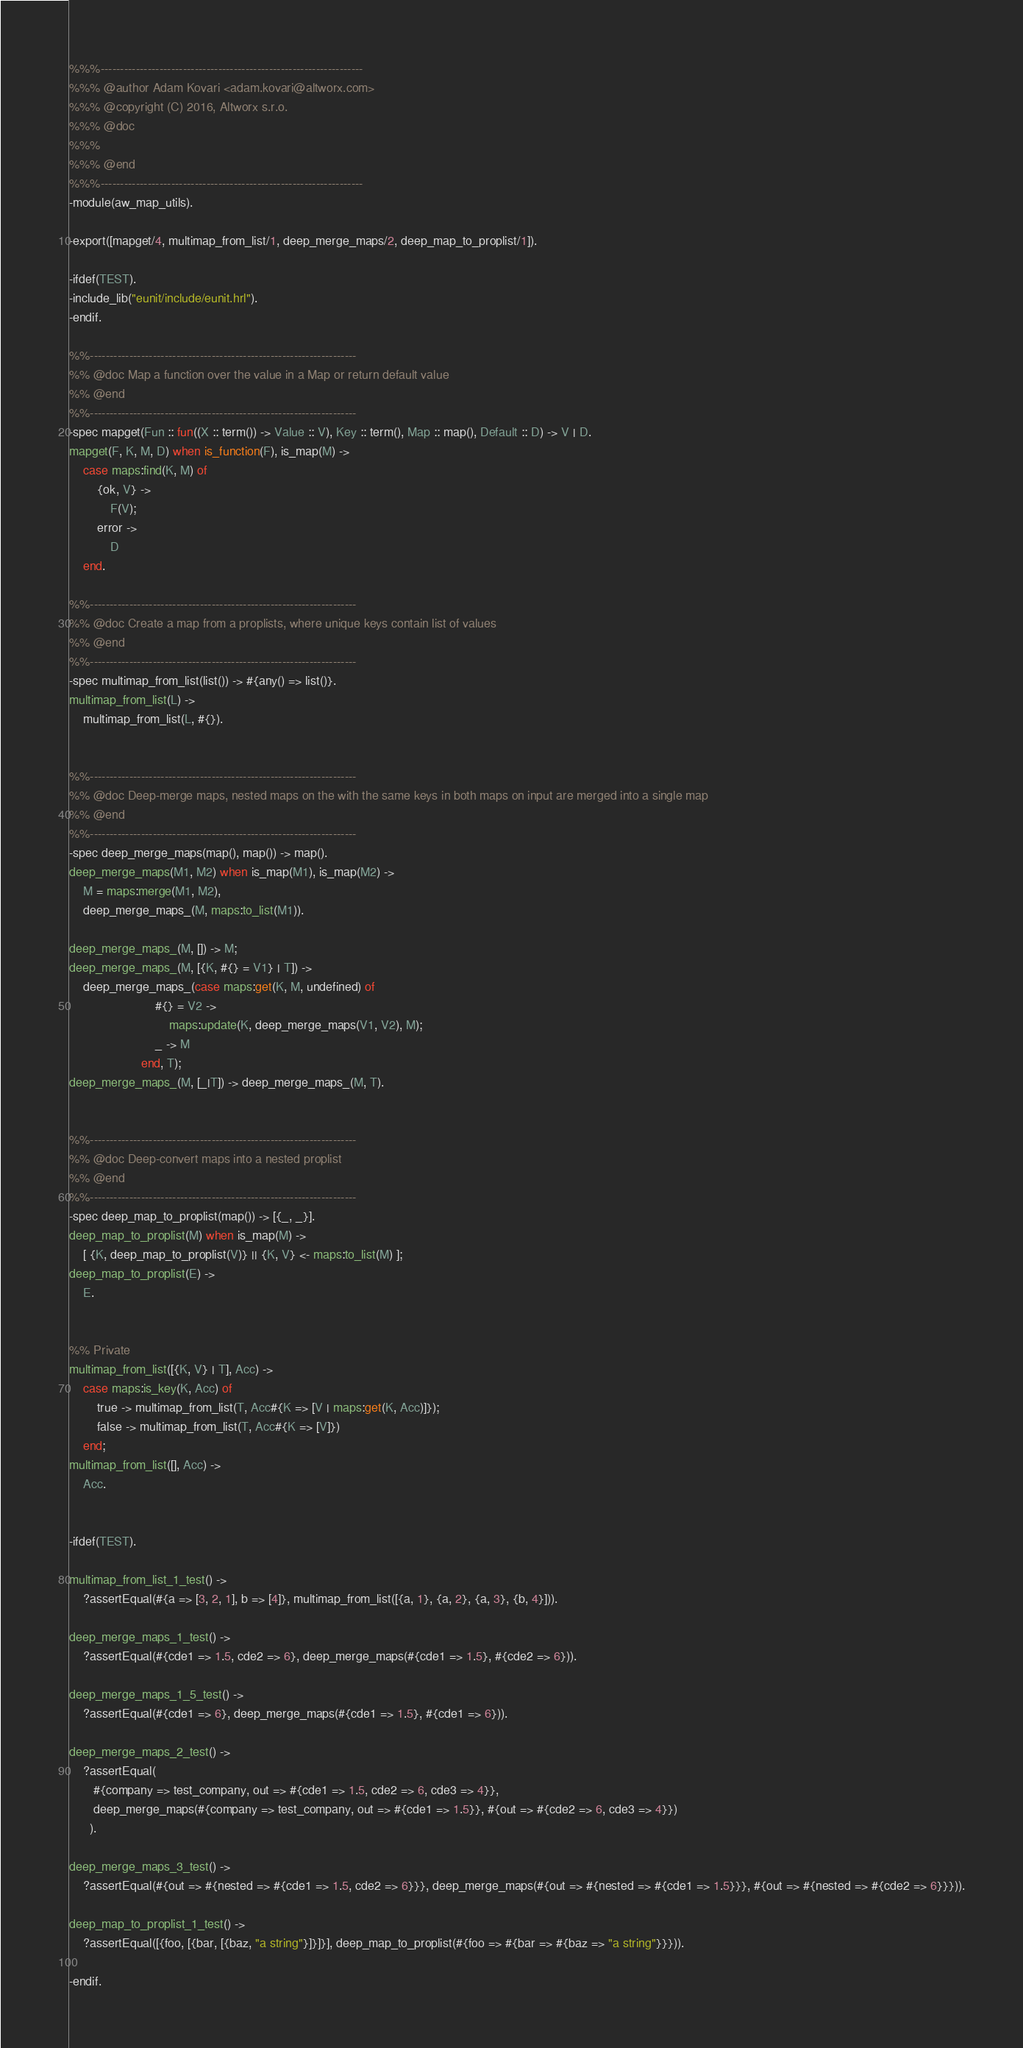<code> <loc_0><loc_0><loc_500><loc_500><_Erlang_>%%%-------------------------------------------------------------------
%%% @author Adam Kovari <adam.kovari@altworx.com>
%%% @copyright (C) 2016, Altworx s.r.o.
%%% @doc
%%%
%%% @end
%%%-------------------------------------------------------------------
-module(aw_map_utils).

-export([mapget/4, multimap_from_list/1, deep_merge_maps/2, deep_map_to_proplist/1]).

-ifdef(TEST).
-include_lib("eunit/include/eunit.hrl").
-endif.

%%--------------------------------------------------------------------
%% @doc Map a function over the value in a Map or return default value
%% @end
%%--------------------------------------------------------------------
-spec mapget(Fun :: fun((X :: term()) -> Value :: V), Key :: term(), Map :: map(), Default :: D) -> V | D.
mapget(F, K, M, D) when is_function(F), is_map(M) ->
    case maps:find(K, M) of
        {ok, V} ->
            F(V);
        error ->
            D
    end.

%%--------------------------------------------------------------------
%% @doc Create a map from a proplists, where unique keys contain list of values
%% @end
%%--------------------------------------------------------------------
-spec multimap_from_list(list()) -> #{any() => list()}.
multimap_from_list(L) ->
    multimap_from_list(L, #{}).


%%--------------------------------------------------------------------
%% @doc Deep-merge maps, nested maps on the with the same keys in both maps on input are merged into a single map
%% @end
%%--------------------------------------------------------------------
-spec deep_merge_maps(map(), map()) -> map().
deep_merge_maps(M1, M2) when is_map(M1), is_map(M2) ->
    M = maps:merge(M1, M2),
    deep_merge_maps_(M, maps:to_list(M1)).

deep_merge_maps_(M, []) -> M;
deep_merge_maps_(M, [{K, #{} = V1} | T]) ->
    deep_merge_maps_(case maps:get(K, M, undefined) of
                         #{} = V2 ->
                             maps:update(K, deep_merge_maps(V1, V2), M);
                         _ -> M
                     end, T);
deep_merge_maps_(M, [_|T]) -> deep_merge_maps_(M, T).


%%--------------------------------------------------------------------
%% @doc Deep-convert maps into a nested proplist
%% @end
%%--------------------------------------------------------------------
-spec deep_map_to_proplist(map()) -> [{_, _}].
deep_map_to_proplist(M) when is_map(M) ->
    [ {K, deep_map_to_proplist(V)} || {K, V} <- maps:to_list(M) ];
deep_map_to_proplist(E) ->
    E.


%% Private
multimap_from_list([{K, V} | T], Acc) ->
    case maps:is_key(K, Acc) of
        true -> multimap_from_list(T, Acc#{K => [V | maps:get(K, Acc)]});
        false -> multimap_from_list(T, Acc#{K => [V]})
    end;
multimap_from_list([], Acc) ->
    Acc.


-ifdef(TEST).

multimap_from_list_1_test() ->
    ?assertEqual(#{a => [3, 2, 1], b => [4]}, multimap_from_list([{a, 1}, {a, 2}, {a, 3}, {b, 4}])).

deep_merge_maps_1_test() ->
    ?assertEqual(#{cde1 => 1.5, cde2 => 6}, deep_merge_maps(#{cde1 => 1.5}, #{cde2 => 6})).

deep_merge_maps_1_5_test() ->
    ?assertEqual(#{cde1 => 6}, deep_merge_maps(#{cde1 => 1.5}, #{cde1 => 6})).

deep_merge_maps_2_test() ->
    ?assertEqual(
       #{company => test_company, out => #{cde1 => 1.5, cde2 => 6, cde3 => 4}},
       deep_merge_maps(#{company => test_company, out => #{cde1 => 1.5}}, #{out => #{cde2 => 6, cde3 => 4}})
      ).

deep_merge_maps_3_test() ->
    ?assertEqual(#{out => #{nested => #{cde1 => 1.5, cde2 => 6}}}, deep_merge_maps(#{out => #{nested => #{cde1 => 1.5}}}, #{out => #{nested => #{cde2 => 6}}})).

deep_map_to_proplist_1_test() ->
    ?assertEqual([{foo, [{bar, [{baz, "a string"}]}]}], deep_map_to_proplist(#{foo => #{bar => #{baz => "a string"}}})).

-endif.
</code> 